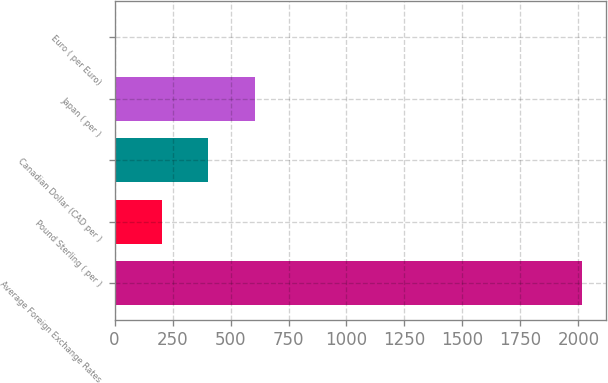Convert chart to OTSL. <chart><loc_0><loc_0><loc_500><loc_500><bar_chart><fcel>Average Foreign Exchange Rates<fcel>Pound Sterling ( per )<fcel>Canadian Dollar (CAD per )<fcel>Japan ( per )<fcel>Euro ( per Euro)<nl><fcel>2017<fcel>202.72<fcel>404.31<fcel>605.9<fcel>1.13<nl></chart> 